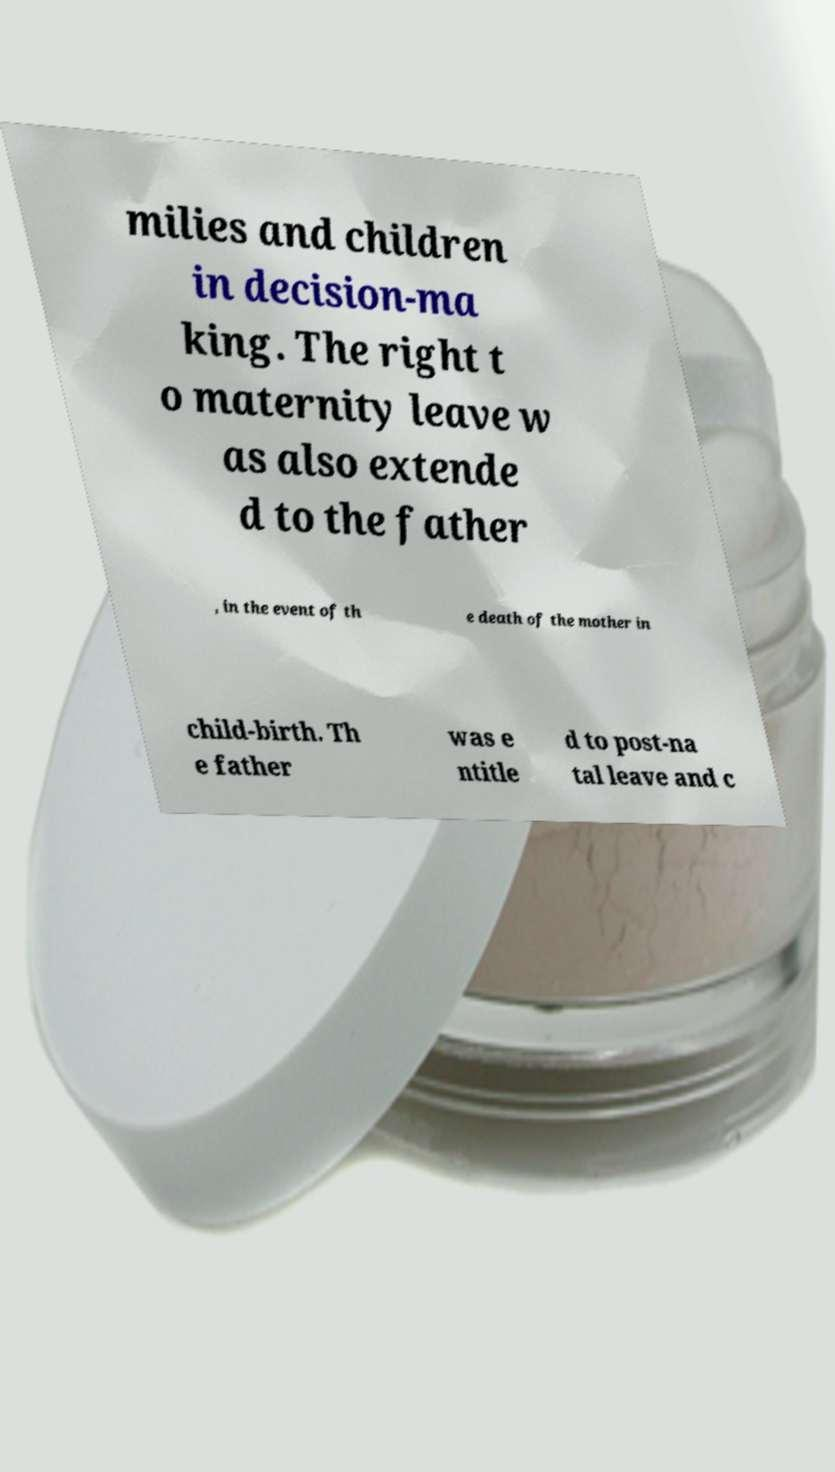Can you accurately transcribe the text from the provided image for me? milies and children in decision-ma king. The right t o maternity leave w as also extende d to the father , in the event of th e death of the mother in child-birth. Th e father was e ntitle d to post-na tal leave and c 